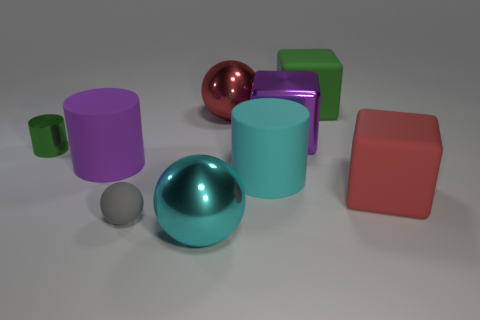There is a matte thing that is on the left side of the green rubber cube and right of the cyan metallic sphere; how big is it?
Offer a terse response. Large. Do the small green metal thing and the small matte object have the same shape?
Offer a terse response. No. What is the shape of the big purple thing that is made of the same material as the gray sphere?
Your response must be concise. Cylinder. How many small objects are gray matte balls or green matte things?
Your response must be concise. 1. Is there a large red rubber object that is in front of the large cube right of the green matte block?
Offer a very short reply. No. Are any big blue cylinders visible?
Offer a terse response. No. There is a big metallic sphere to the right of the large shiny thing that is in front of the cyan rubber thing; what color is it?
Keep it short and to the point. Red. There is a large red thing that is the same shape as the big purple metal thing; what material is it?
Offer a terse response. Rubber. What number of gray matte things have the same size as the matte sphere?
Provide a short and direct response. 0. There is a green thing that is the same material as the cyan cylinder; what size is it?
Make the answer very short. Large. 